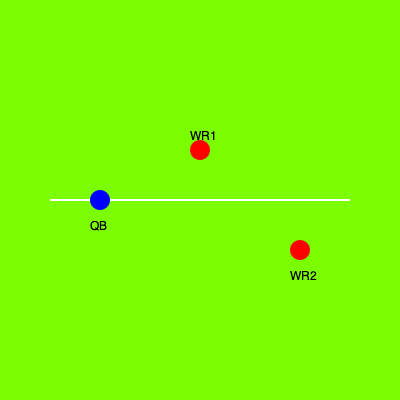In this bird's-eye view of a play formation, estimate the distance between WR1 and WR2 in yards, given that the distance between the QB and WR1 is 10 yards. To estimate the distance between WR1 and WR2, we can use the Pythagorean theorem and the given information:

1. The QB to WR1 distance is 10 yards.
2. The field is represented by a coordinate system where:
   - QB is at (0, 0)
   - WR1 is at (10, -5) [10 yards forward, 5 yards up]
   - WR2 is at (20, 5) [20 yards forward, 5 yards down]

3. Calculate the horizontal distance between WR1 and WR2:
   $20 - 10 = 10$ yards

4. Calculate the vertical distance between WR1 and WR2:
   $5 - (-5) = 10$ yards

5. Apply the Pythagorean theorem:
   $d^2 = 10^2 + 10^2$
   $d^2 = 100 + 100 = 200$
   $d = \sqrt{200} \approx 14.14$ yards

6. Round to the nearest yard:
   $14.14$ yards ≈ $14$ yards

Therefore, the estimated distance between WR1 and WR2 is approximately 14 yards.
Answer: 14 yards 